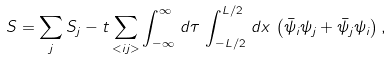Convert formula to latex. <formula><loc_0><loc_0><loc_500><loc_500>S = \sum _ { j } S _ { j } - t \sum _ { < i j > } \int _ { - \infty } ^ { \infty } \, d \tau \, \int _ { - L / 2 } ^ { L / 2 } \, d x \, \left ( \bar { \psi } _ { i } \psi _ { j } + \bar { \psi } _ { j } \psi _ { i } \right ) ,</formula> 